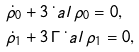<formula> <loc_0><loc_0><loc_500><loc_500>& \dot { \rho } _ { 0 } + 3 \, \dot { \ } a l \, \rho _ { 0 } = 0 , \\ & \dot { \rho } _ { 1 } + 3 \, \Gamma \, \dot { \ } a l \, \rho _ { 1 } = 0 ,</formula> 